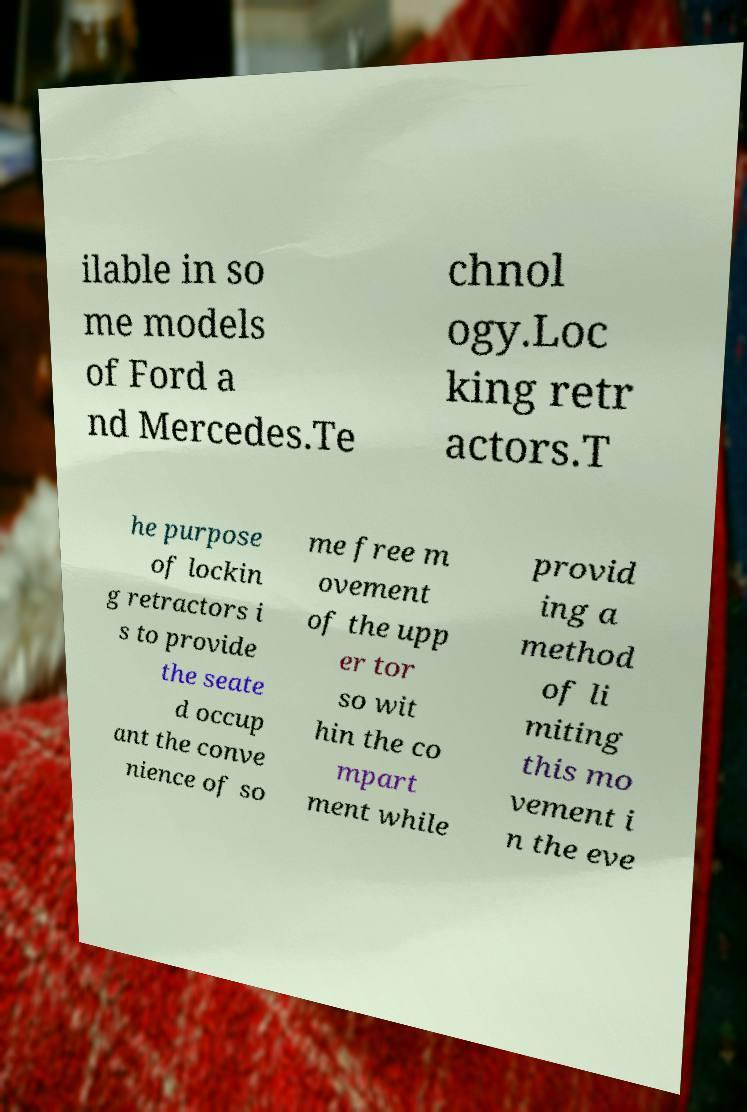What messages or text are displayed in this image? I need them in a readable, typed format. ilable in so me models of Ford a nd Mercedes.Te chnol ogy.Loc king retr actors.T he purpose of lockin g retractors i s to provide the seate d occup ant the conve nience of so me free m ovement of the upp er tor so wit hin the co mpart ment while provid ing a method of li miting this mo vement i n the eve 